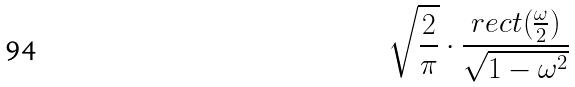Convert formula to latex. <formula><loc_0><loc_0><loc_500><loc_500>\sqrt { \frac { 2 } { \pi } } \cdot \frac { r e c t ( \frac { \omega } { 2 } ) } { \sqrt { 1 - \omega ^ { 2 } } }</formula> 